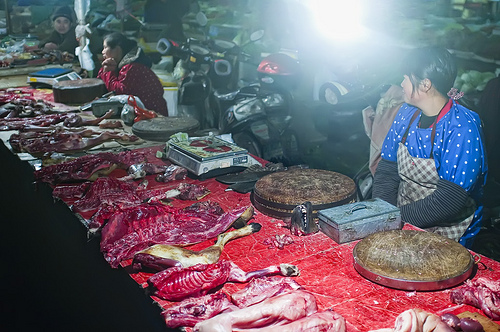<image>
Is there a animal meat under the girl? No. The animal meat is not positioned under the girl. The vertical relationship between these objects is different. Is the woman behind the table? Yes. From this viewpoint, the woman is positioned behind the table, with the table partially or fully occluding the woman. 